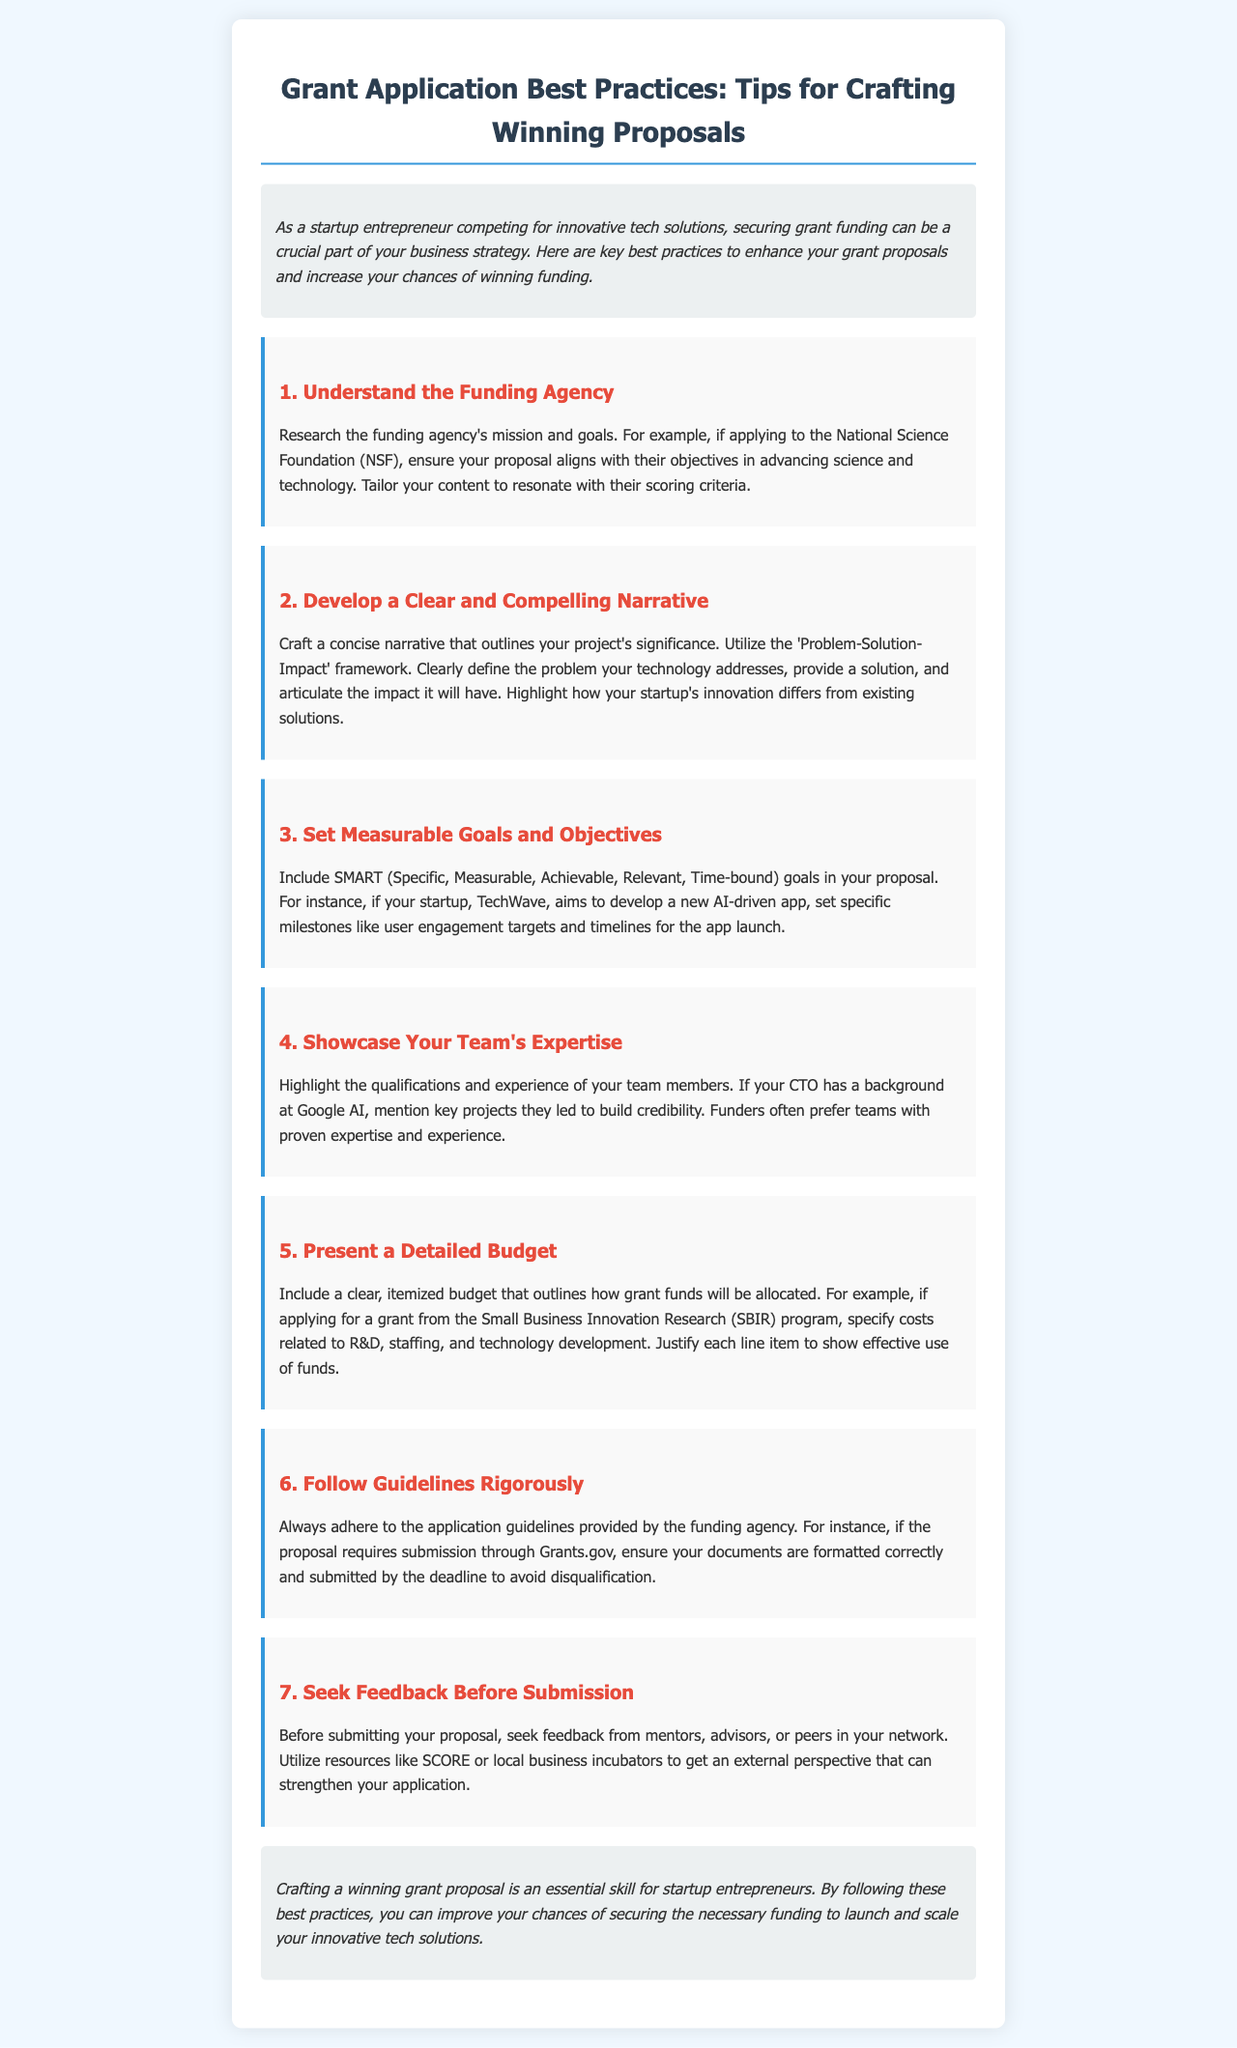What is the main purpose of the newsletter? The main purpose of the newsletter is to provide key best practices to enhance grant proposals for entrepreneurs seeking funding.
Answer: To enhance grant proposals What framework is recommended for developing a narrative? The newsletter suggests using the 'Problem-Solution-Impact' framework to outline the project's significance.
Answer: Problem-Solution-Impact What should the goals in the proposal adhere to? The goals in the proposal should adhere to the SMART criteria, which ensures they are well-defined and actionable.
Answer: SMART Which funding agency is specifically mentioned regarding alignment of objectives? The National Science Foundation (NSF) is mentioned as an example for aligning proposal objectives with agency goals.
Answer: National Science Foundation What is the first step recommended in the grant application process? The first step is to understand the funding agency and its mission before drafting the proposal.
Answer: Understand the funding agency What type of feedback is suggested before submission? The newsletter recommends seeking feedback from mentors, advisors, or peers within your network to strengthen your application.
Answer: Feedback from mentors What aspect should be thoroughly detailed in the proposal? A detailed budget itemizing how grant funds will be allocated should be included in the proposal.
Answer: A detailed budget What element of the team should be highlighted in the proposal? The qualifications and experience of team members, especially their relevant expertise, should be highlighted.
Answer: Team's expertise What are the consequences of not following application guidelines? Not following application guidelines can lead to disqualification of the proposal.
Answer: Disqualification 